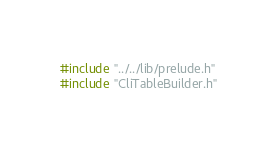<code> <loc_0><loc_0><loc_500><loc_500><_C++_>#include "../../lib/prelude.h"
#include "CliTableBuilder.h"
</code> 